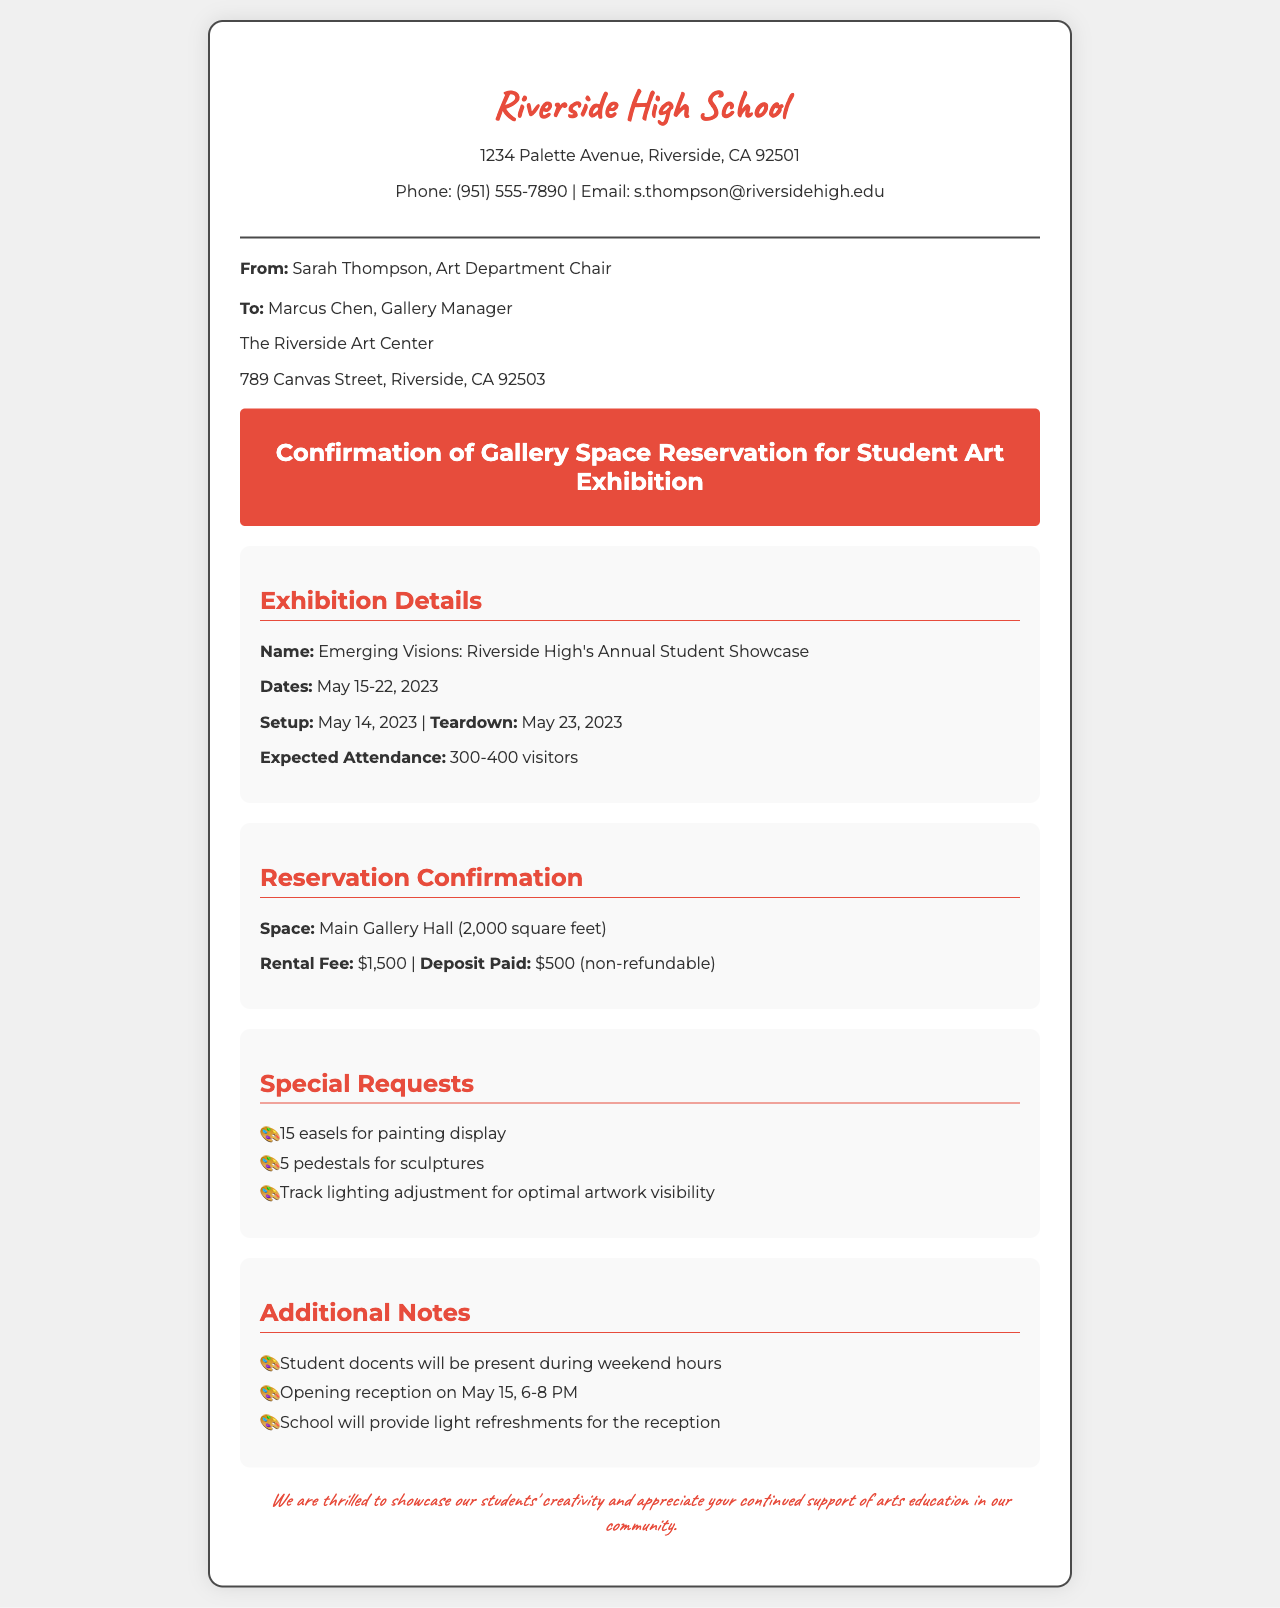what is the name of the exhibition? The name of the exhibition is specified in the document under "Exhibition Details".
Answer: Emerging Visions: Riverside High's Annual Student Showcase when is the exhibition set up? The setup date is listed in the details of the exhibition.
Answer: May 14, 2023 what is the rental fee for the gallery space? The rental fee is mentioned in the "Reservation Confirmation" section of the document.
Answer: $1,500 how many expected visitors are there? The expected attendance is given under "Exhibition Details".
Answer: 300-400 visitors what special request involves lighting? A specific special request regarding lighting is made in the document.
Answer: Track lighting adjustment for optimal artwork visibility who is the sender of the fax? The sender's information is provided at the beginning of the document.
Answer: Sarah Thompson, Art Department Chair what is the opening reception time? The opening reception time is detailed in the "Additional Notes" section.
Answer: 6-8 PM where is the gallery located? The location of the gallery is mentioned in the recipient's information.
Answer: 789 Canvas Street, Riverside, CA 92503 